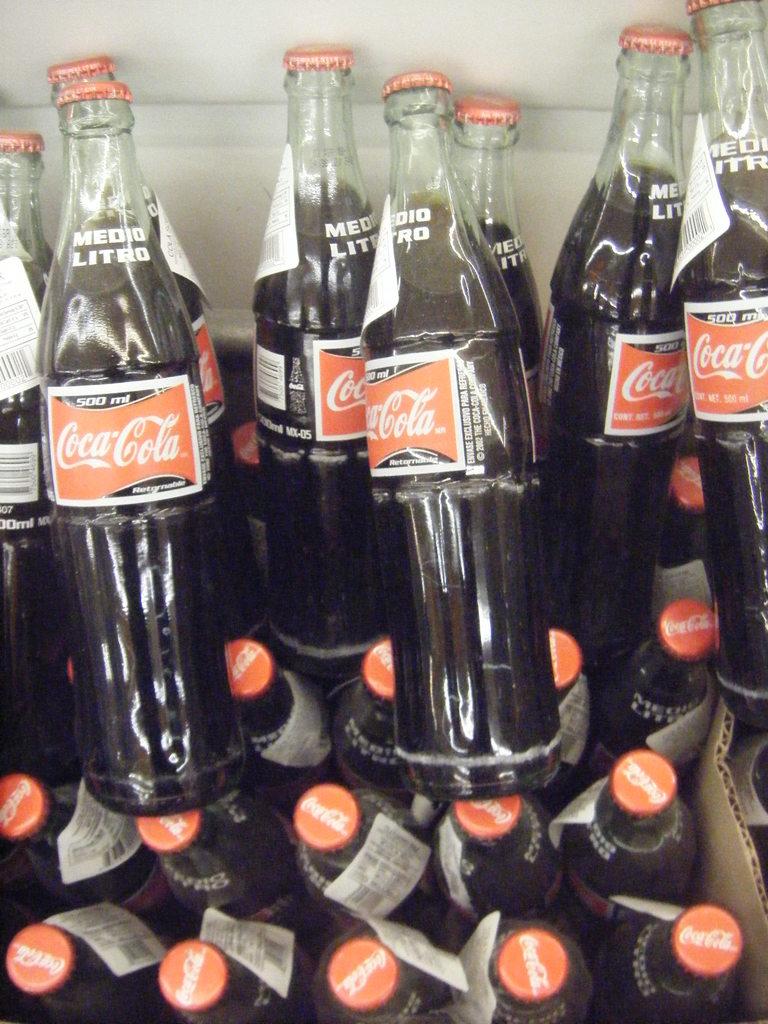How many milliliters does each bottle of soda contain?
Your answer should be compact. 500. What brand of soda is this?
Make the answer very short. Coca-cola. 